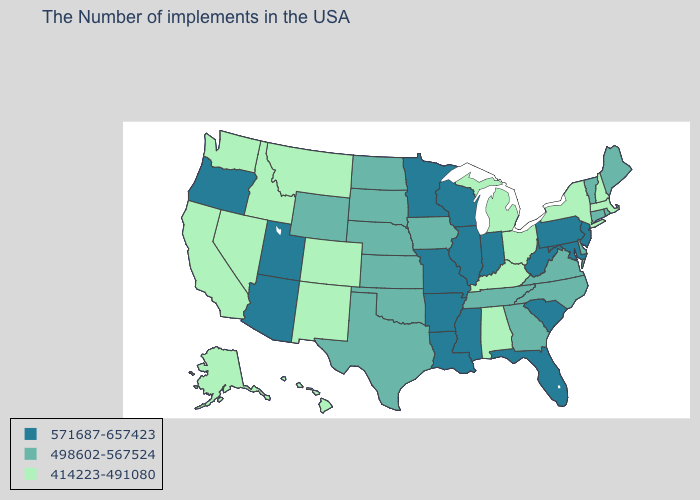How many symbols are there in the legend?
Concise answer only. 3. What is the lowest value in the West?
Concise answer only. 414223-491080. Does the first symbol in the legend represent the smallest category?
Be succinct. No. Name the states that have a value in the range 414223-491080?
Answer briefly. Massachusetts, New Hampshire, New York, Ohio, Michigan, Kentucky, Alabama, Colorado, New Mexico, Montana, Idaho, Nevada, California, Washington, Alaska, Hawaii. Does Virginia have the lowest value in the South?
Short answer required. No. Name the states that have a value in the range 414223-491080?
Concise answer only. Massachusetts, New Hampshire, New York, Ohio, Michigan, Kentucky, Alabama, Colorado, New Mexico, Montana, Idaho, Nevada, California, Washington, Alaska, Hawaii. What is the value of Rhode Island?
Answer briefly. 498602-567524. Name the states that have a value in the range 571687-657423?
Keep it brief. New Jersey, Maryland, Pennsylvania, South Carolina, West Virginia, Florida, Indiana, Wisconsin, Illinois, Mississippi, Louisiana, Missouri, Arkansas, Minnesota, Utah, Arizona, Oregon. Name the states that have a value in the range 498602-567524?
Quick response, please. Maine, Rhode Island, Vermont, Connecticut, Delaware, Virginia, North Carolina, Georgia, Tennessee, Iowa, Kansas, Nebraska, Oklahoma, Texas, South Dakota, North Dakota, Wyoming. What is the lowest value in the USA?
Keep it brief. 414223-491080. Name the states that have a value in the range 414223-491080?
Answer briefly. Massachusetts, New Hampshire, New York, Ohio, Michigan, Kentucky, Alabama, Colorado, New Mexico, Montana, Idaho, Nevada, California, Washington, Alaska, Hawaii. Does Pennsylvania have the highest value in the Northeast?
Write a very short answer. Yes. Name the states that have a value in the range 414223-491080?
Write a very short answer. Massachusetts, New Hampshire, New York, Ohio, Michigan, Kentucky, Alabama, Colorado, New Mexico, Montana, Idaho, Nevada, California, Washington, Alaska, Hawaii. Name the states that have a value in the range 498602-567524?
Write a very short answer. Maine, Rhode Island, Vermont, Connecticut, Delaware, Virginia, North Carolina, Georgia, Tennessee, Iowa, Kansas, Nebraska, Oklahoma, Texas, South Dakota, North Dakota, Wyoming. What is the value of Utah?
Keep it brief. 571687-657423. 